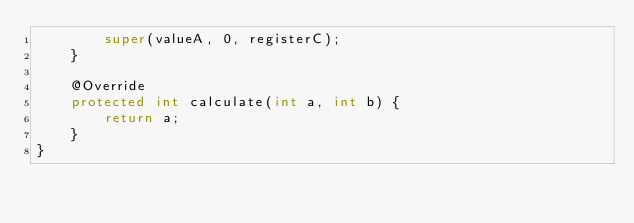Convert code to text. <code><loc_0><loc_0><loc_500><loc_500><_Java_>		super(valueA, 0, registerC);
	}

	@Override
	protected int calculate(int a, int b) {
		return a;
	}
}
</code> 